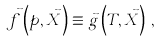Convert formula to latex. <formula><loc_0><loc_0><loc_500><loc_500>\vec { f } \left ( p , \vec { X } \right ) \equiv \vec { g } \left ( T , \vec { X } \right ) \, ,</formula> 